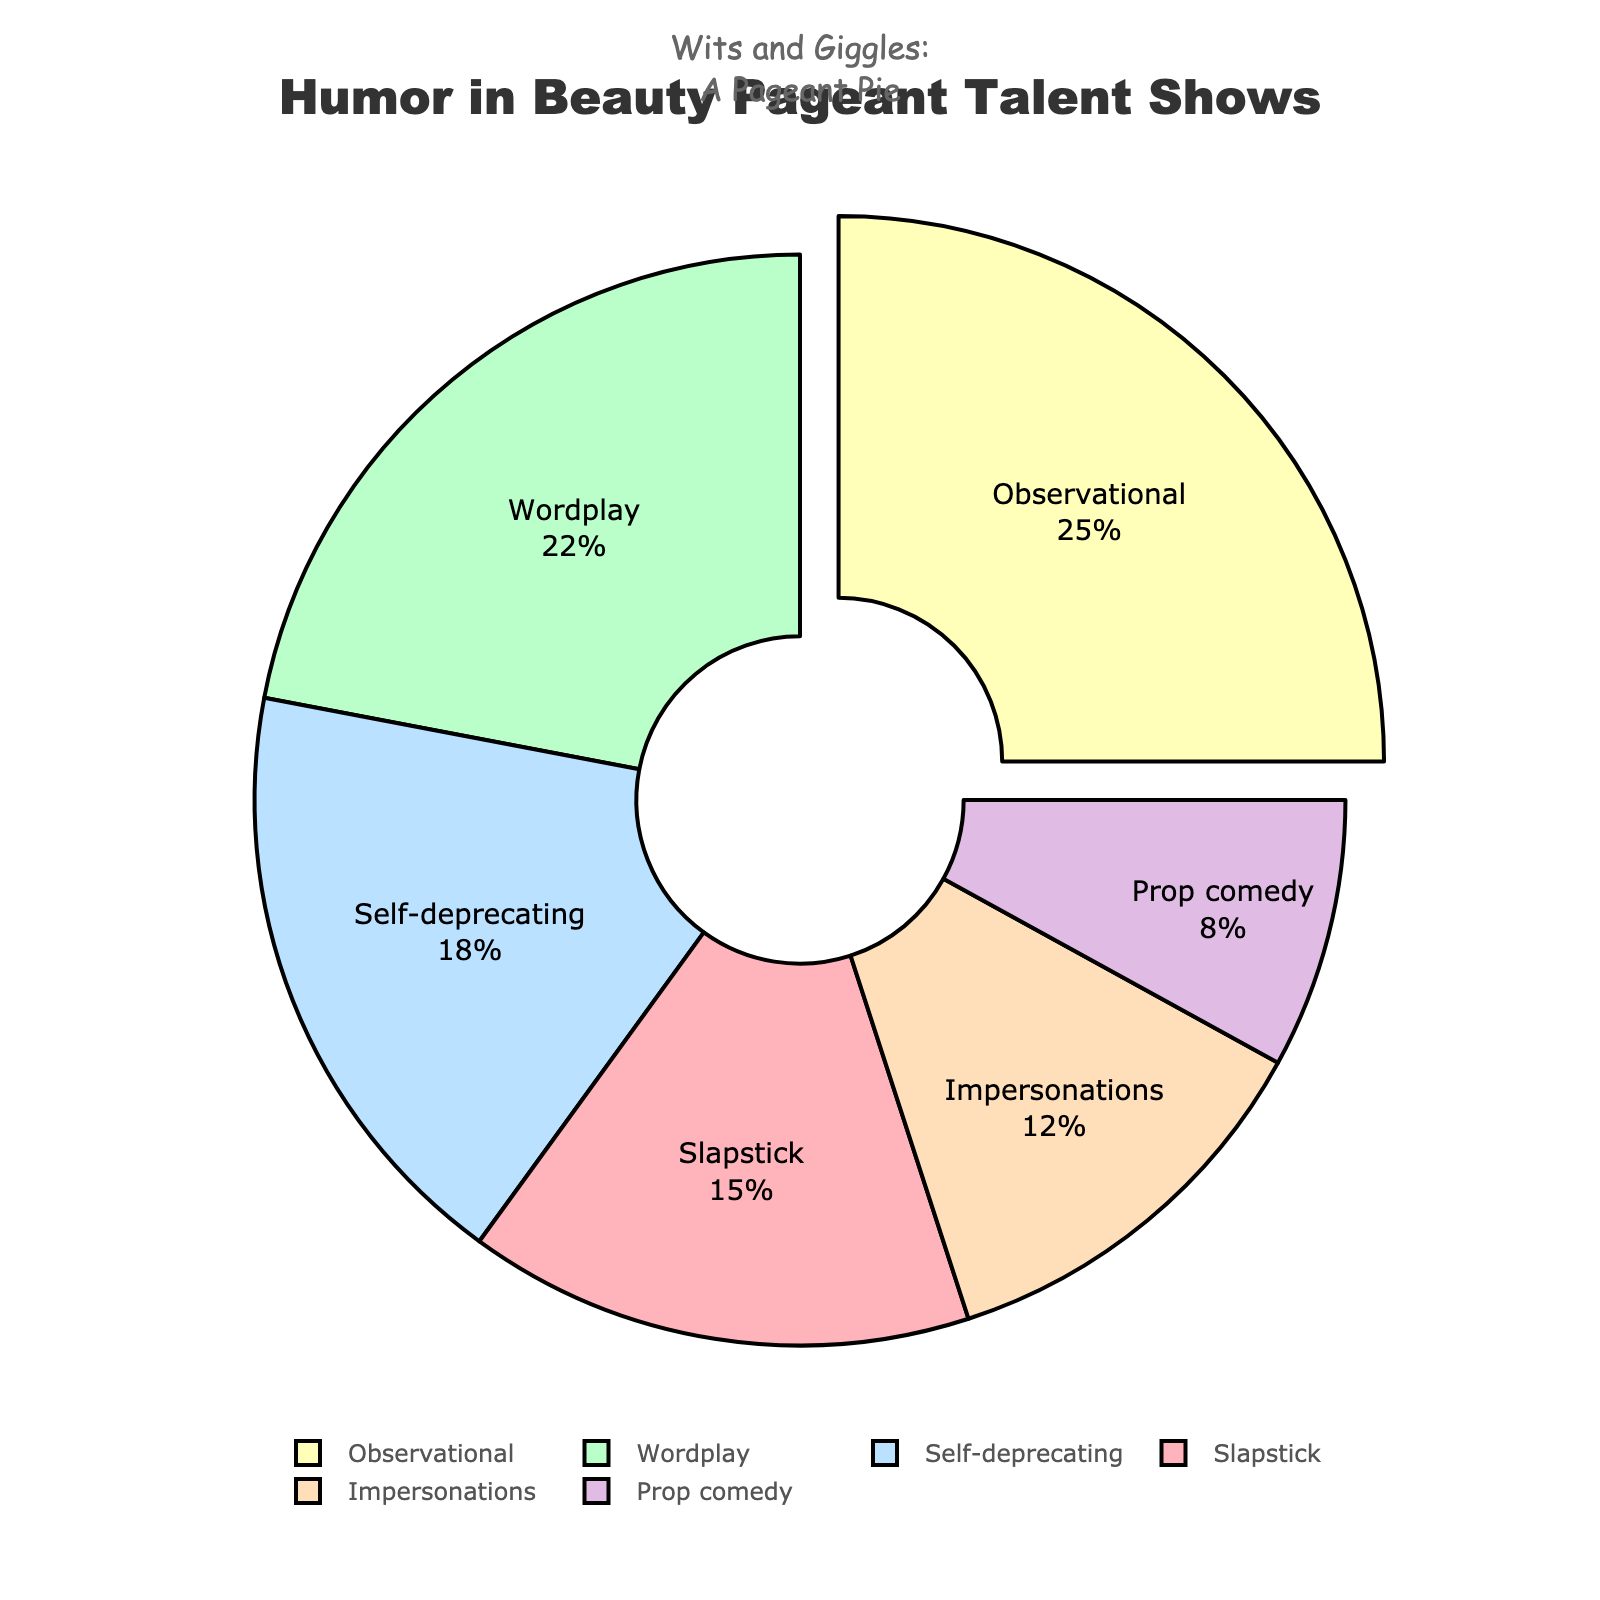What type of humor has the highest proportion in beauty pageant talent performances? Observational humor has the highest proportion. This can be determined by looking at the segment that is slightly pulled out from the pie chart, which marks it as the largest slice.
Answer: Observational Which type of humor is the least used in the performances? Prop comedy is the least used type, accounting for just 8% of the total types of humor. This is the smallest slice on the pie chart.
Answer: Prop comedy How much more popular is Wordplay humor compared to Impersonations? Wordplay humor accounts for 22%, and Impersonations account for 12%. The difference between their proportions is 22% - 12% = 10%.
Answer: 10% Which two types of humor together make up exactly 40% of the total? Observational humor makes up 25%, and Prop comedy makes up 8%, which together make 25% + 8% = 33%. Self-deprecating humor is 18% and Prop comedy is 8%, together making 18% + 8% = 26%. Observational humor and Self-deprecating humor together make up 25% + 18% = 43%. Observational humor and Wordplay humor together make 25% + 22% = 47%. Therefore, Wordplay (22%) and Slapstick (15%) together make 22% + 15% = 37%. Hence, no two types combine exactly to form 40%.
Answer: None What is the average percentage of Slapstick and Observational humor? The percentage for Slapstick is 15%, and Observational humor is 25%. The average is calculated as (15% + 25%) / 2 = 20%.
Answer: 20% Are there more comedic performances using Self-deprecating humor than Slapstick humor? Yes, Self-deprecating humor accounts for 18%, while Slapstick humor accounts for 15%. Thus, Self-deprecating humor is more commonly used.
Answer: Yes What color represents Wordplay humor in the pie chart? The pie chart uses different colors for different types of humor, and Wordplay humor is represented by a greenish color. This can be identified by locating the slice labeled "Wordplay" on the pie chart.
Answer: greenish How do the combined percentages of Self-deprecating and prop comedy compare to Observational humor? Self-deprecating humor has 18%, and prop comedy has 8%, combined that's 18% + 8% = 26%. Observational humor alone accounts for 25%. So, the combined percentages of Self-deprecating and prop comedy are 1% higher than Observational humor.
Answer: 1% higher Which humor type is depicted using a yellow color in the pie chart? Observational humor is depicted using a yellow color. This can be identified by looking at the slice labeled "Observational" and observing its color.
Answer: Observational What percentage range is covered by the top three types of humor in terms of popularity? Observational humor is 25%, Wordplay humor is 22%, and Self-deprecating humor is 18%. Adding these gives a range from 18% to 25%.
Answer: 18%-25% 